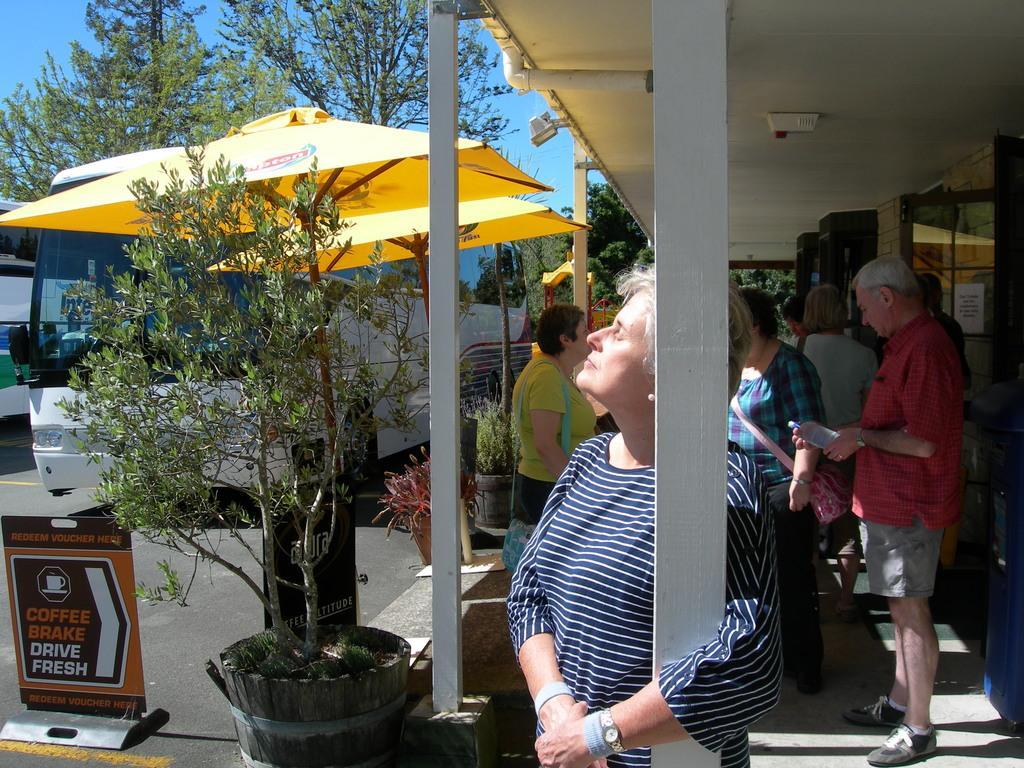How would you summarize this image in a sentence or two? This picture describes about group of people, they are standing under the roof, in the middle of the given image we can see a woman, she is holding a pillar, in front of them we can see trees, an umbrellas, sign board and vehicles. 